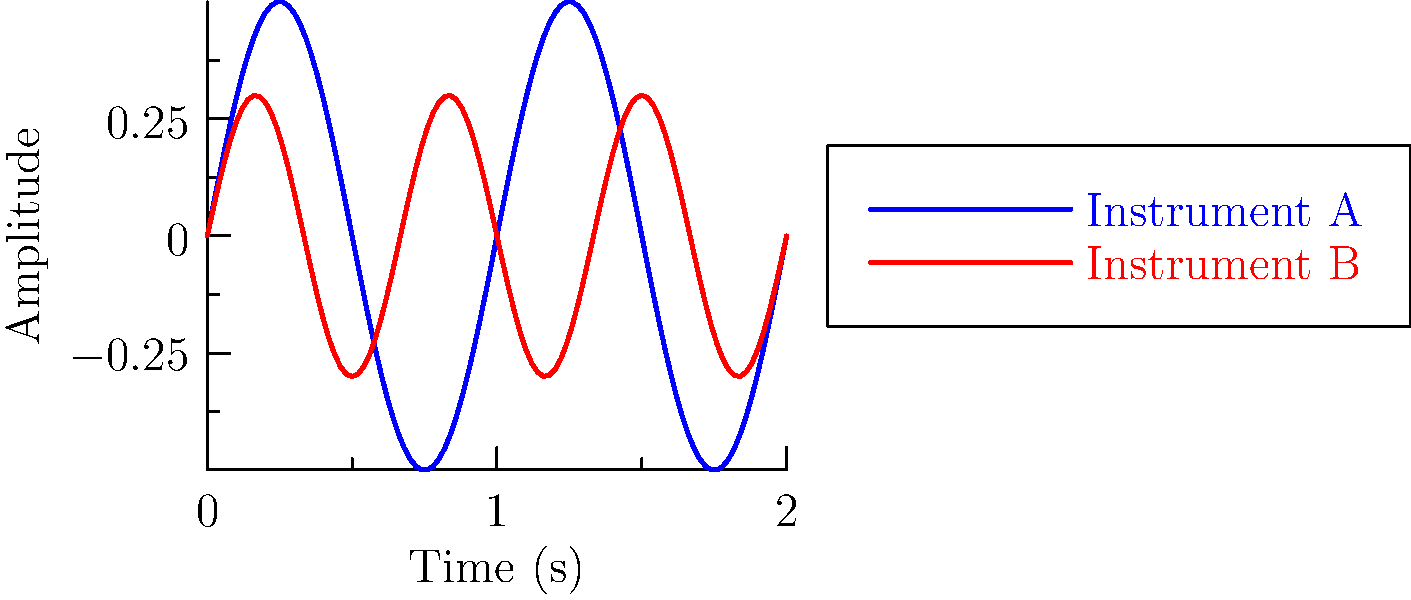The waveforms of two reconstructed ancient musical instruments are shown above. Which instrument has a higher frequency, and by what factor? To determine which instrument has a higher frequency and by what factor, we need to analyze the waveforms:

1. Frequency is related to the number of cycles completed in a given time period.
2. Observe that Instrument A (blue) completes 1 full cycle in the given time frame.
3. Instrument B (red) completes 1.5 cycles in the same time frame.
4. To calculate the frequency ratio:
   - Let $f_A$ be the frequency of Instrument A
   - Let $f_B$ be the frequency of Instrument B
   - Ratio = $\frac{f_B}{f_A} = \frac{1.5}{1} = 1.5$
5. Therefore, Instrument B has a higher frequency.
6. The frequency of Instrument B is 1.5 times that of Instrument A.
Answer: Instrument B; 1.5 times 